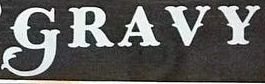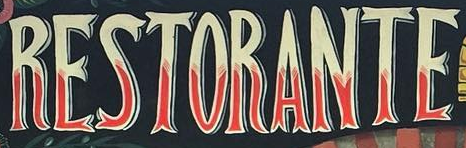Read the text content from these images in order, separated by a semicolon. GRAVY; RESTORANTE 